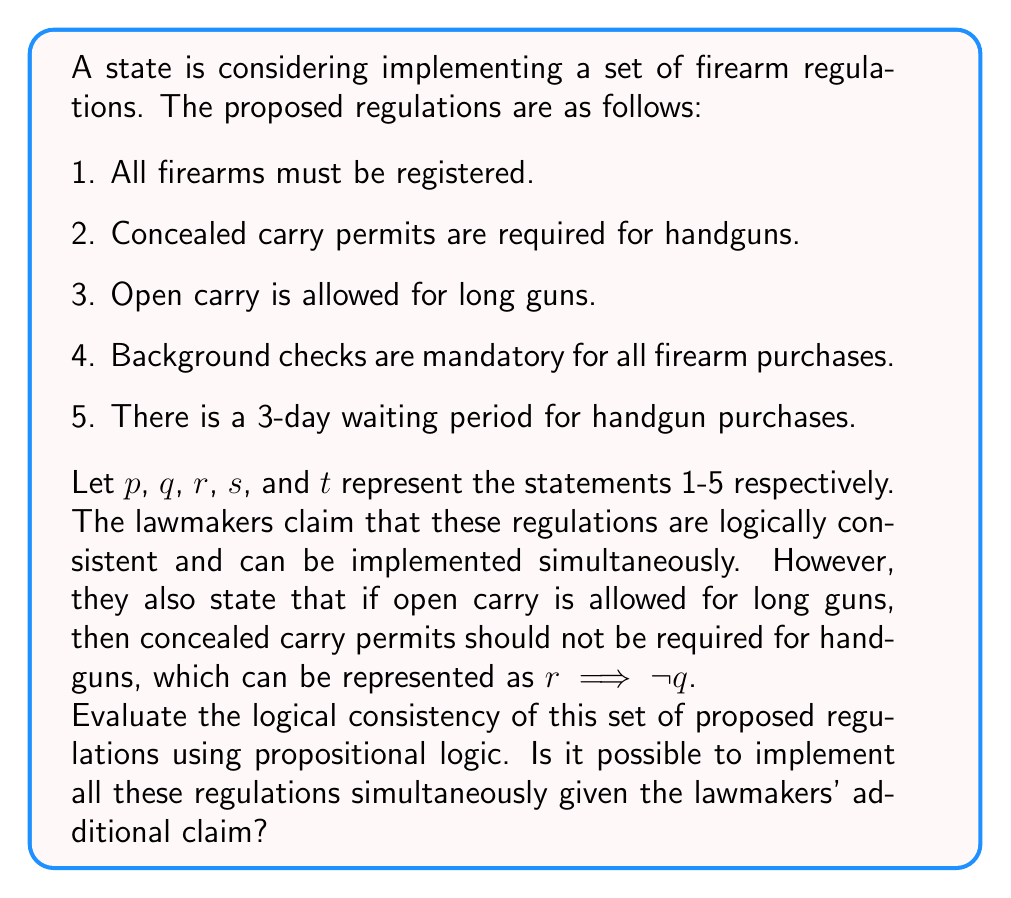Could you help me with this problem? To evaluate the logical consistency of the proposed regulations, we need to determine if there's a contradiction between the given statements and the additional claim made by the lawmakers.

Step 1: Express the given information in logical form.
- The set of regulations: $p \land q \land r \land s \land t$
- The lawmakers' additional claim: $r \implies \neg q$

Step 2: Check for contradiction.
We need to see if it's possible for both $(p \land q \land r \land s \land t)$ and $(r \implies \neg q)$ to be true simultaneously.

Step 3: Analyze the implications.
From the set of regulations, we know that $r$ (open carry is allowed for long guns) and $q$ (concealed carry permits are required for handguns) are both true.

However, the lawmakers' claim states that if $r$ is true, then $q$ must be false $(r \implies \neg q)$.

Step 4: Identify the contradiction.
We have:
$r$ is true (from the regulations)
$q$ is true (from the regulations)
$r \implies \neg q$ (from the lawmakers' claim)

This creates a logical contradiction because:
1. $r$ is true
2. If $r$ is true, then $\neg q$ must be true (from $r \implies \neg q$)
3. But $q$ is also stated to be true in the regulations

Step 5: Conclusion.
The set of proposed regulations is not logically consistent with the lawmakers' additional claim. It's impossible to implement all these regulations simultaneously while maintaining the condition that open carry for long guns implies no concealed carry permits for handguns.
Answer: Logically inconsistent 